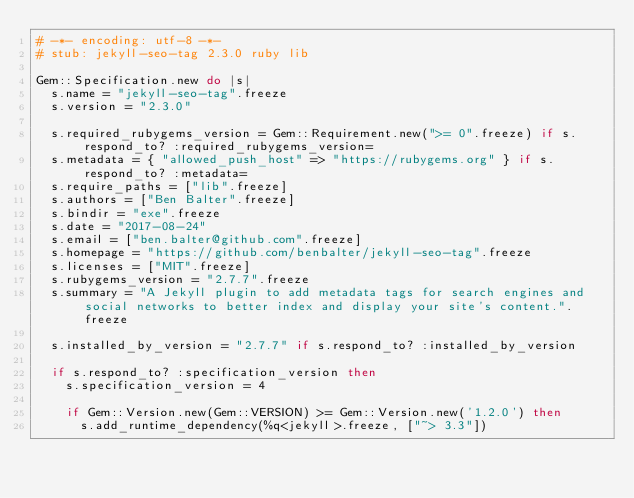Convert code to text. <code><loc_0><loc_0><loc_500><loc_500><_Ruby_># -*- encoding: utf-8 -*-
# stub: jekyll-seo-tag 2.3.0 ruby lib

Gem::Specification.new do |s|
  s.name = "jekyll-seo-tag".freeze
  s.version = "2.3.0"

  s.required_rubygems_version = Gem::Requirement.new(">= 0".freeze) if s.respond_to? :required_rubygems_version=
  s.metadata = { "allowed_push_host" => "https://rubygems.org" } if s.respond_to? :metadata=
  s.require_paths = ["lib".freeze]
  s.authors = ["Ben Balter".freeze]
  s.bindir = "exe".freeze
  s.date = "2017-08-24"
  s.email = ["ben.balter@github.com".freeze]
  s.homepage = "https://github.com/benbalter/jekyll-seo-tag".freeze
  s.licenses = ["MIT".freeze]
  s.rubygems_version = "2.7.7".freeze
  s.summary = "A Jekyll plugin to add metadata tags for search engines and social networks to better index and display your site's content.".freeze

  s.installed_by_version = "2.7.7" if s.respond_to? :installed_by_version

  if s.respond_to? :specification_version then
    s.specification_version = 4

    if Gem::Version.new(Gem::VERSION) >= Gem::Version.new('1.2.0') then
      s.add_runtime_dependency(%q<jekyll>.freeze, ["~> 3.3"])</code> 